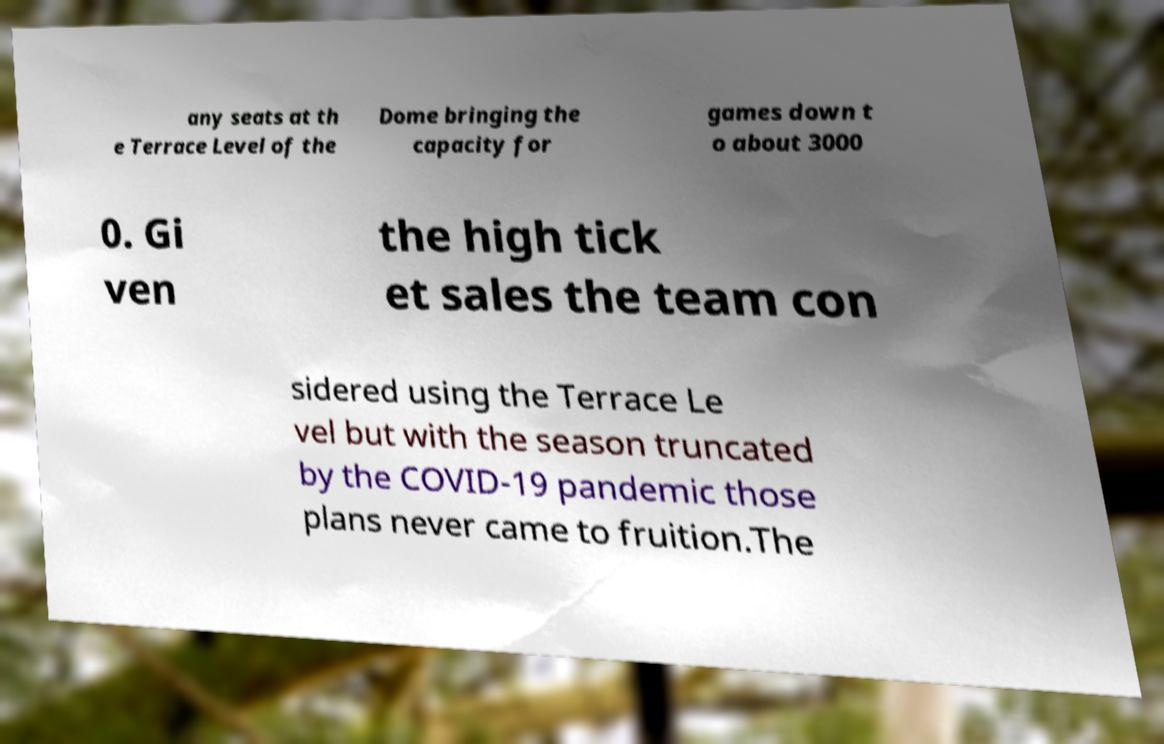For documentation purposes, I need the text within this image transcribed. Could you provide that? any seats at th e Terrace Level of the Dome bringing the capacity for games down t o about 3000 0. Gi ven the high tick et sales the team con sidered using the Terrace Le vel but with the season truncated by the COVID-19 pandemic those plans never came to fruition.The 